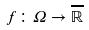Convert formula to latex. <formula><loc_0><loc_0><loc_500><loc_500>f \colon \Omega \rightarrow \overline { \mathbb { R } }</formula> 